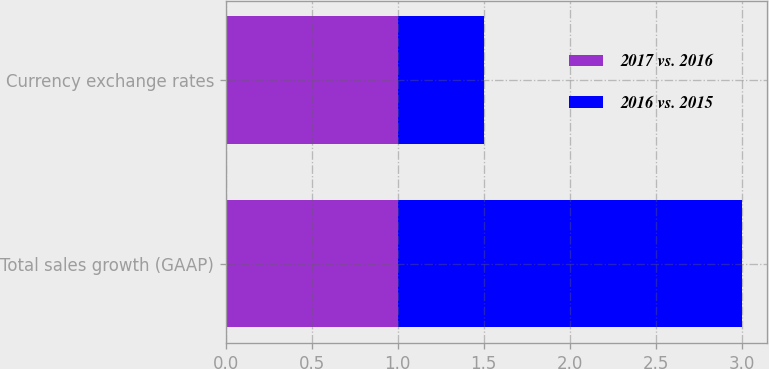Convert chart to OTSL. <chart><loc_0><loc_0><loc_500><loc_500><stacked_bar_chart><ecel><fcel>Total sales growth (GAAP)<fcel>Currency exchange rates<nl><fcel>2017 vs. 2016<fcel>1<fcel>1<nl><fcel>2016 vs. 2015<fcel>2<fcel>0.5<nl></chart> 